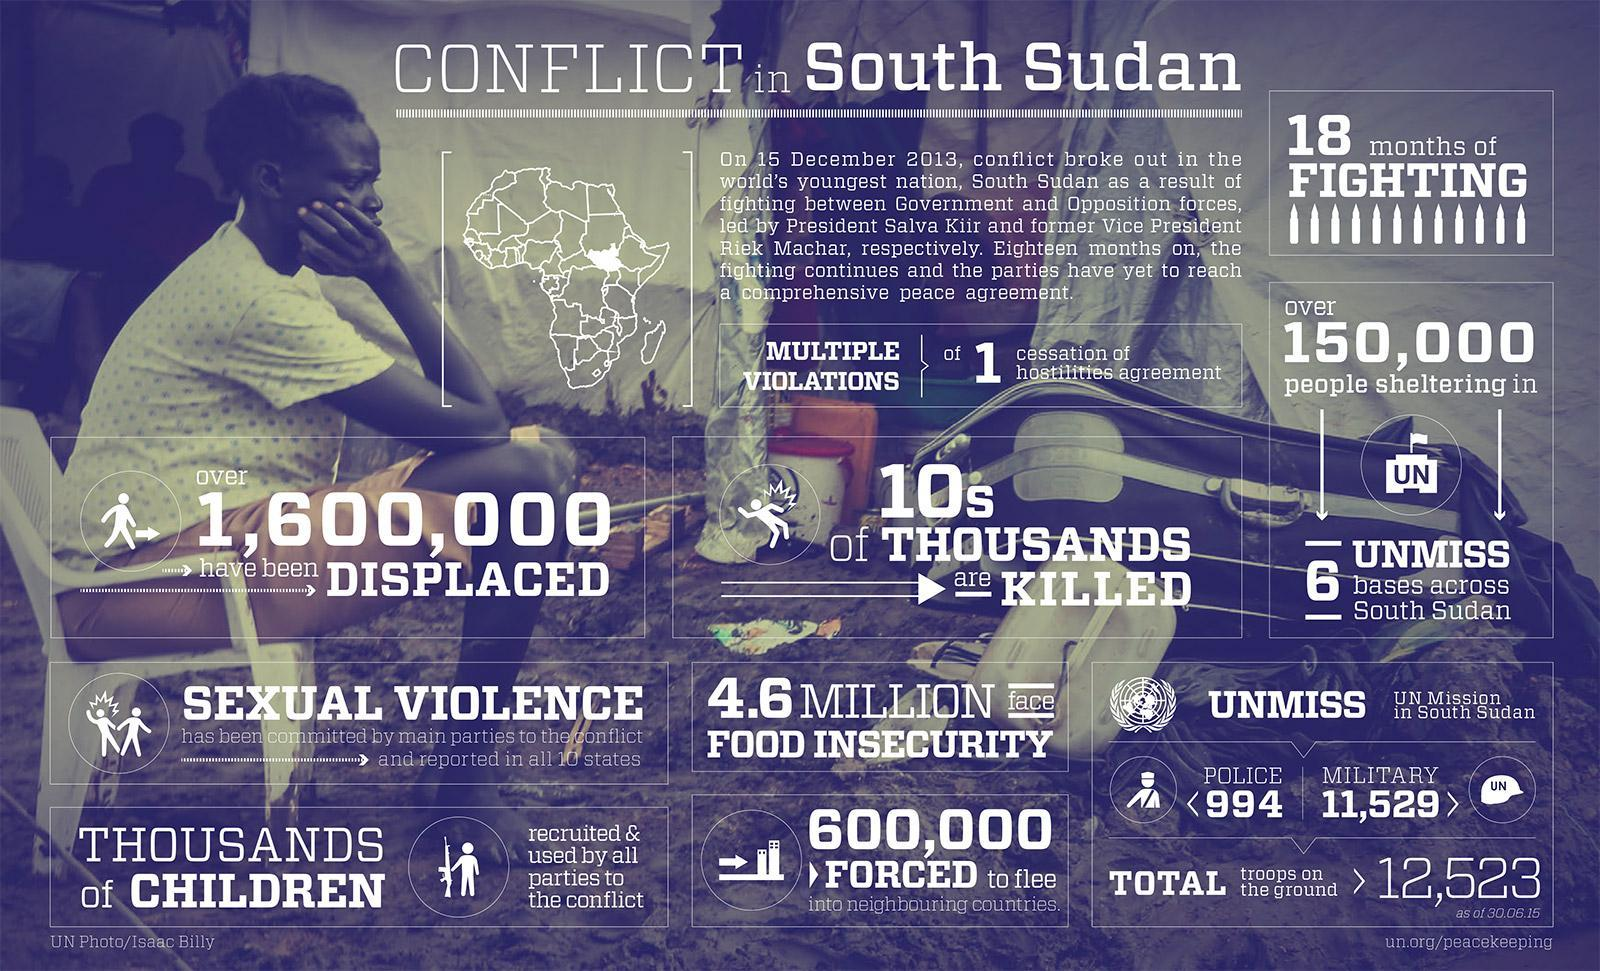How many police forces were deployed in the UNMISS mission?
Answer the question with a short phrase. 994 How many military troops were deployed in the UNMISS mission? 11,529 What population in South Sudan were forced to flee as a result of conflict outbreak in December 2013? 600,000 